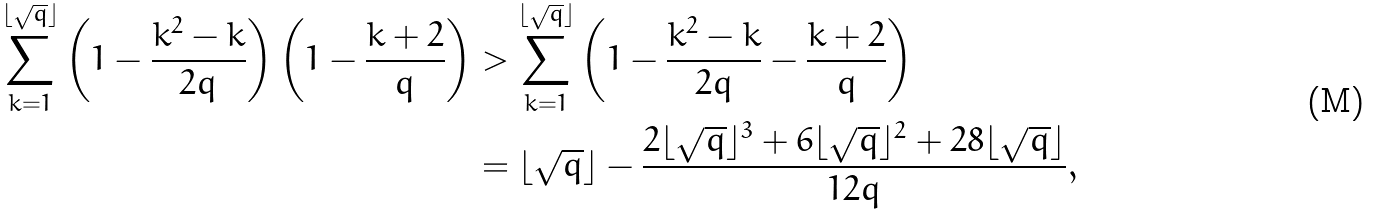Convert formula to latex. <formula><loc_0><loc_0><loc_500><loc_500>\sum _ { k = 1 } ^ { \lfloor \sqrt { q } \rfloor } { \left ( 1 - \frac { k ^ { 2 } - k } { 2 q } \right ) \left ( 1 - \frac { k + 2 } { q } \right ) } & > \sum _ { k = 1 } ^ { \lfloor \sqrt { q } \rfloor } { \left ( 1 - \frac { k ^ { 2 } - k } { 2 q } - \frac { k + 2 } { q } \right ) } \\ & = \lfloor \sqrt { q } \rfloor - \frac { 2 \lfloor \sqrt { q } \rfloor ^ { 3 } + 6 \lfloor \sqrt { q } \rfloor ^ { 2 } + 2 8 \lfloor \sqrt { q } \rfloor } { 1 2 q } ,</formula> 